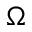<formula> <loc_0><loc_0><loc_500><loc_500>\Omega</formula> 